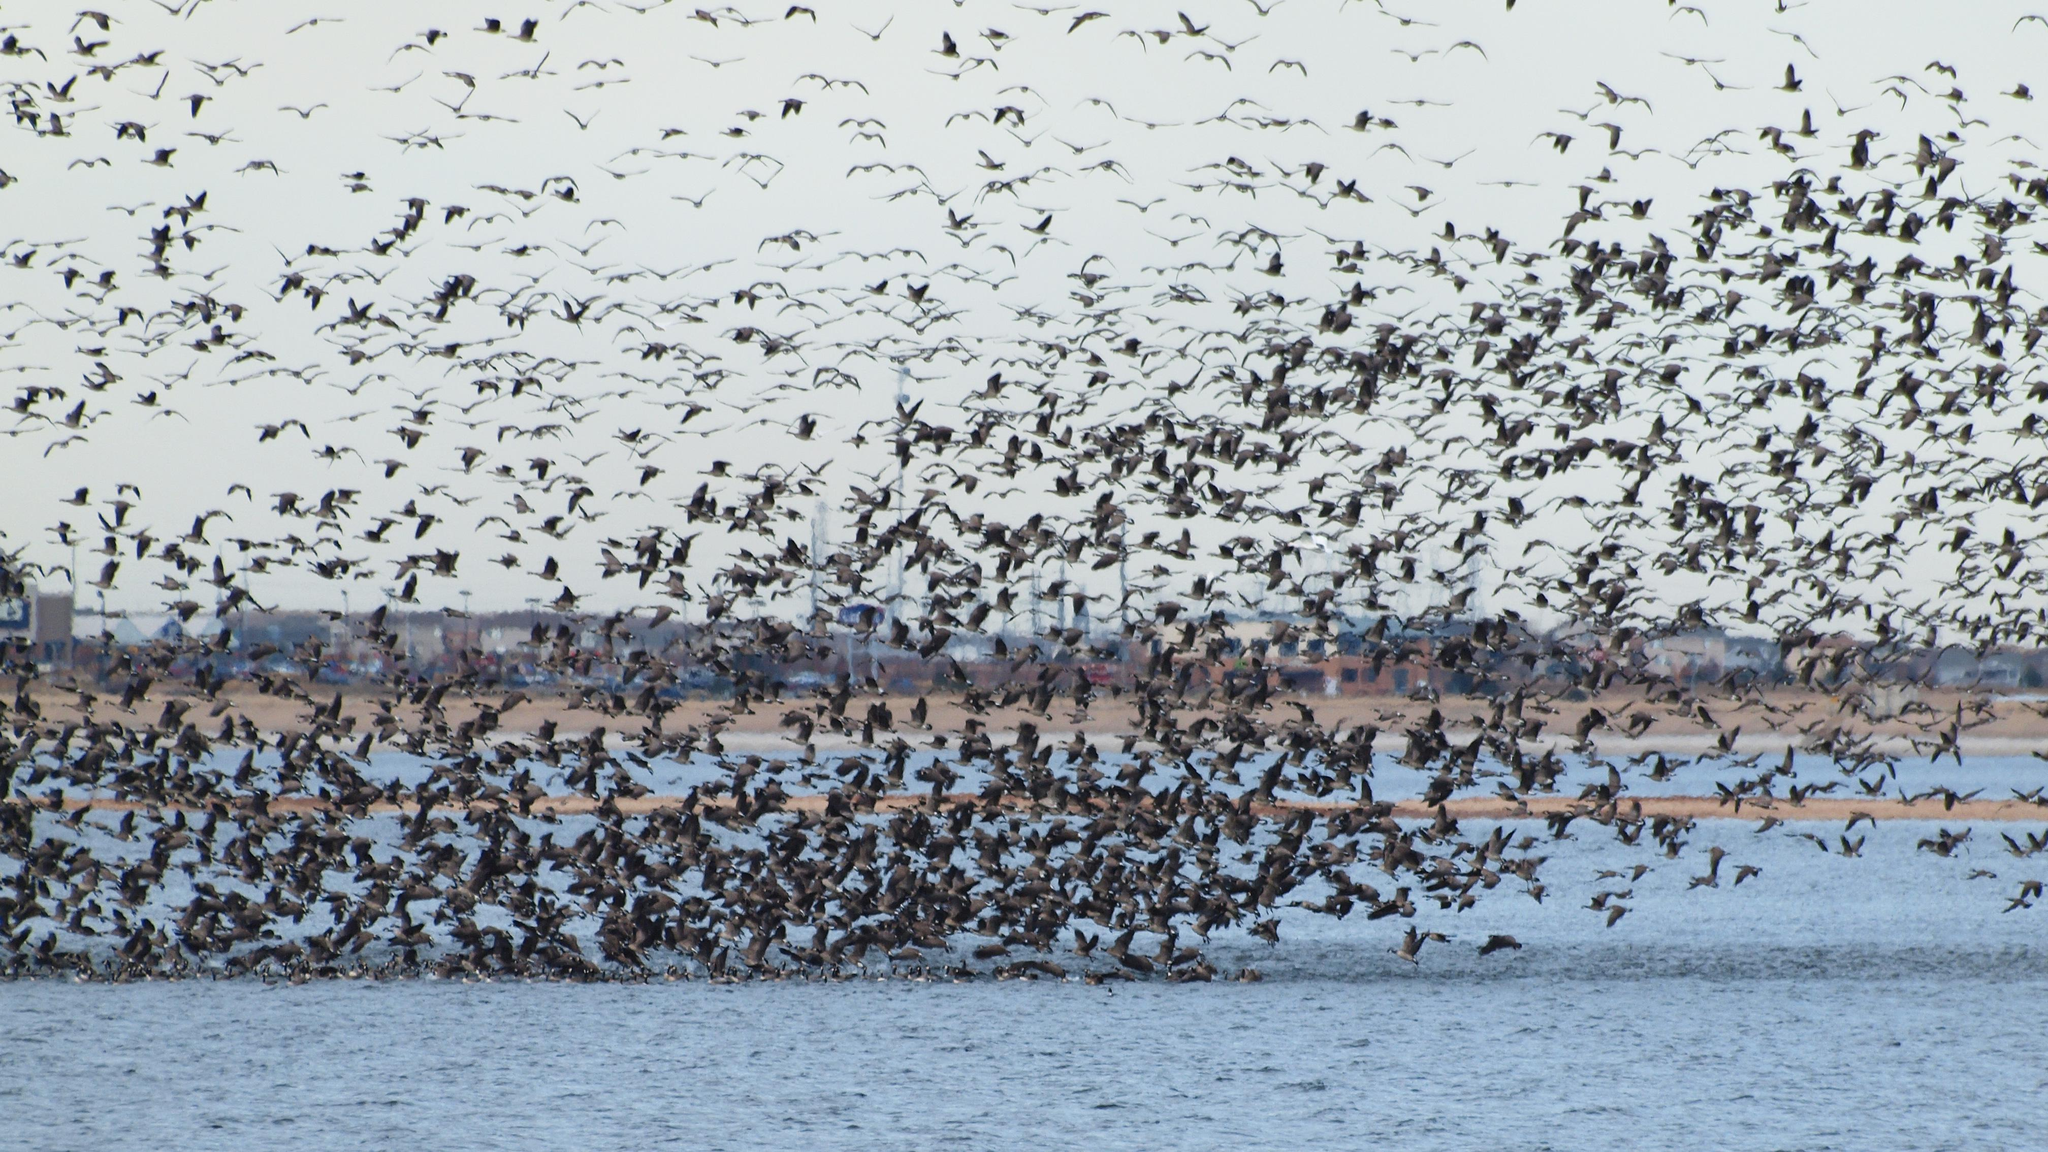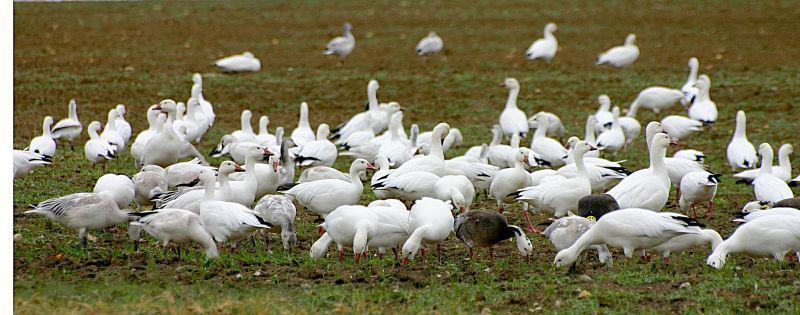The first image is the image on the left, the second image is the image on the right. Given the left and right images, does the statement "In one image, white ducks and geese are congregated on a green grassy field." hold true? Answer yes or no. Yes. The first image is the image on the left, the second image is the image on the right. Assess this claim about the two images: "There is water in the image on the left.". Correct or not? Answer yes or no. Yes. 